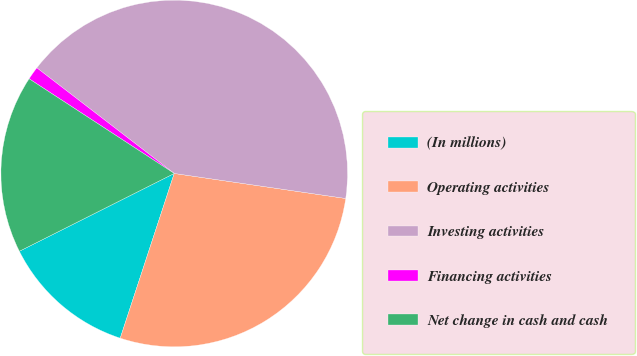Convert chart. <chart><loc_0><loc_0><loc_500><loc_500><pie_chart><fcel>(In millions)<fcel>Operating activities<fcel>Investing activities<fcel>Financing activities<fcel>Net change in cash and cash<nl><fcel>12.55%<fcel>27.74%<fcel>41.88%<fcel>1.23%<fcel>16.61%<nl></chart> 